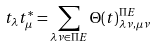<formula> <loc_0><loc_0><loc_500><loc_500>t _ { \lambda } t ^ { * } _ { \mu } = \sum _ { \lambda \nu \in \Pi E } \Theta ( t ) ^ { \Pi E } _ { \lambda \nu , \mu \nu }</formula> 